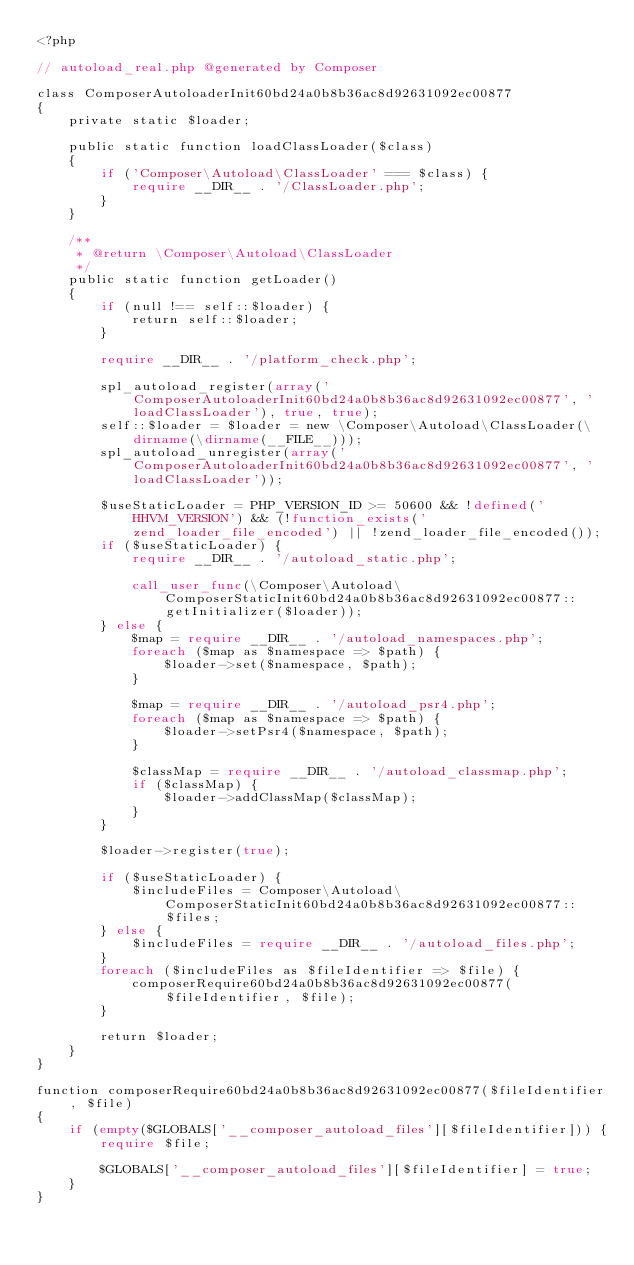<code> <loc_0><loc_0><loc_500><loc_500><_PHP_><?php

// autoload_real.php @generated by Composer

class ComposerAutoloaderInit60bd24a0b8b36ac8d92631092ec00877
{
    private static $loader;

    public static function loadClassLoader($class)
    {
        if ('Composer\Autoload\ClassLoader' === $class) {
            require __DIR__ . '/ClassLoader.php';
        }
    }

    /**
     * @return \Composer\Autoload\ClassLoader
     */
    public static function getLoader()
    {
        if (null !== self::$loader) {
            return self::$loader;
        }

        require __DIR__ . '/platform_check.php';

        spl_autoload_register(array('ComposerAutoloaderInit60bd24a0b8b36ac8d92631092ec00877', 'loadClassLoader'), true, true);
        self::$loader = $loader = new \Composer\Autoload\ClassLoader(\dirname(\dirname(__FILE__)));
        spl_autoload_unregister(array('ComposerAutoloaderInit60bd24a0b8b36ac8d92631092ec00877', 'loadClassLoader'));

        $useStaticLoader = PHP_VERSION_ID >= 50600 && !defined('HHVM_VERSION') && (!function_exists('zend_loader_file_encoded') || !zend_loader_file_encoded());
        if ($useStaticLoader) {
            require __DIR__ . '/autoload_static.php';

            call_user_func(\Composer\Autoload\ComposerStaticInit60bd24a0b8b36ac8d92631092ec00877::getInitializer($loader));
        } else {
            $map = require __DIR__ . '/autoload_namespaces.php';
            foreach ($map as $namespace => $path) {
                $loader->set($namespace, $path);
            }

            $map = require __DIR__ . '/autoload_psr4.php';
            foreach ($map as $namespace => $path) {
                $loader->setPsr4($namespace, $path);
            }

            $classMap = require __DIR__ . '/autoload_classmap.php';
            if ($classMap) {
                $loader->addClassMap($classMap);
            }
        }

        $loader->register(true);

        if ($useStaticLoader) {
            $includeFiles = Composer\Autoload\ComposerStaticInit60bd24a0b8b36ac8d92631092ec00877::$files;
        } else {
            $includeFiles = require __DIR__ . '/autoload_files.php';
        }
        foreach ($includeFiles as $fileIdentifier => $file) {
            composerRequire60bd24a0b8b36ac8d92631092ec00877($fileIdentifier, $file);
        }

        return $loader;
    }
}

function composerRequire60bd24a0b8b36ac8d92631092ec00877($fileIdentifier, $file)
{
    if (empty($GLOBALS['__composer_autoload_files'][$fileIdentifier])) {
        require $file;

        $GLOBALS['__composer_autoload_files'][$fileIdentifier] = true;
    }
}
</code> 